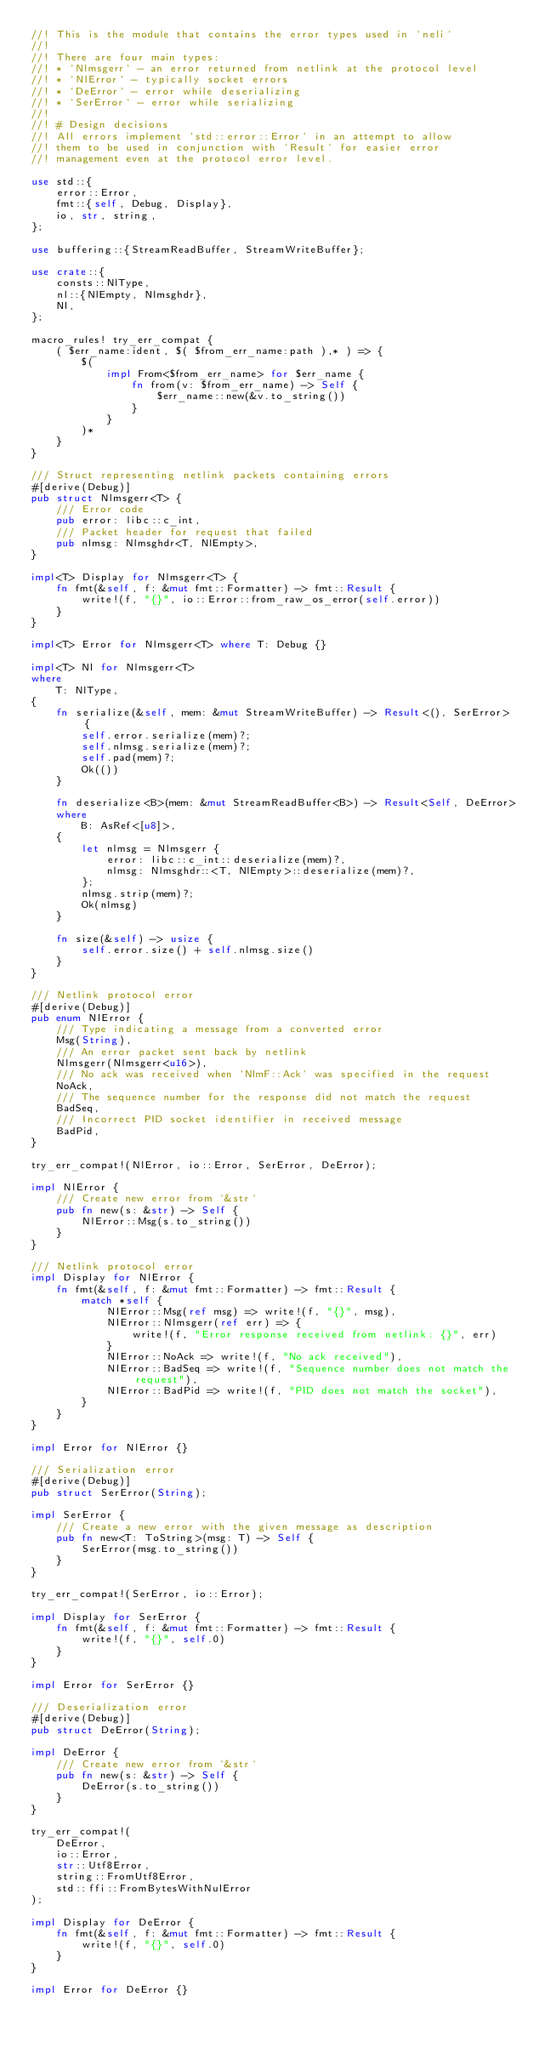<code> <loc_0><loc_0><loc_500><loc_500><_Rust_>//! This is the module that contains the error types used in `neli`
//!
//! There are four main types:
//! * `Nlmsgerr` - an error returned from netlink at the protocol level
//! * `NlError` - typically socket errors
//! * `DeError` - error while deserializing
//! * `SerError` - error while serializing
//!
//! # Design decisions
//! All errors implement `std::error::Error` in an attempt to allow
//! them to be used in conjunction with `Result` for easier error
//! management even at the protocol error level.

use std::{
    error::Error,
    fmt::{self, Debug, Display},
    io, str, string,
};

use buffering::{StreamReadBuffer, StreamWriteBuffer};

use crate::{
    consts::NlType,
    nl::{NlEmpty, Nlmsghdr},
    Nl,
};

macro_rules! try_err_compat {
    ( $err_name:ident, $( $from_err_name:path ),* ) => {
        $(
            impl From<$from_err_name> for $err_name {
                fn from(v: $from_err_name) -> Self {
                    $err_name::new(&v.to_string())
                }
            }
        )*
    }
}

/// Struct representing netlink packets containing errors
#[derive(Debug)]
pub struct Nlmsgerr<T> {
    /// Error code
    pub error: libc::c_int,
    /// Packet header for request that failed
    pub nlmsg: Nlmsghdr<T, NlEmpty>,
}

impl<T> Display for Nlmsgerr<T> {
    fn fmt(&self, f: &mut fmt::Formatter) -> fmt::Result {
        write!(f, "{}", io::Error::from_raw_os_error(self.error))
    }
}

impl<T> Error for Nlmsgerr<T> where T: Debug {}

impl<T> Nl for Nlmsgerr<T>
where
    T: NlType,
{
    fn serialize(&self, mem: &mut StreamWriteBuffer) -> Result<(), SerError> {
        self.error.serialize(mem)?;
        self.nlmsg.serialize(mem)?;
        self.pad(mem)?;
        Ok(())
    }

    fn deserialize<B>(mem: &mut StreamReadBuffer<B>) -> Result<Self, DeError>
    where
        B: AsRef<[u8]>,
    {
        let nlmsg = Nlmsgerr {
            error: libc::c_int::deserialize(mem)?,
            nlmsg: Nlmsghdr::<T, NlEmpty>::deserialize(mem)?,
        };
        nlmsg.strip(mem)?;
        Ok(nlmsg)
    }

    fn size(&self) -> usize {
        self.error.size() + self.nlmsg.size()
    }
}

/// Netlink protocol error
#[derive(Debug)]
pub enum NlError {
    /// Type indicating a message from a converted error
    Msg(String),
    /// An error packet sent back by netlink
    Nlmsgerr(Nlmsgerr<u16>),
    /// No ack was received when `NlmF::Ack` was specified in the request
    NoAck,
    /// The sequence number for the response did not match the request
    BadSeq,
    /// Incorrect PID socket identifier in received message
    BadPid,
}

try_err_compat!(NlError, io::Error, SerError, DeError);

impl NlError {
    /// Create new error from `&str`
    pub fn new(s: &str) -> Self {
        NlError::Msg(s.to_string())
    }
}

/// Netlink protocol error
impl Display for NlError {
    fn fmt(&self, f: &mut fmt::Formatter) -> fmt::Result {
        match *self {
            NlError::Msg(ref msg) => write!(f, "{}", msg),
            NlError::Nlmsgerr(ref err) => {
                write!(f, "Error response received from netlink: {}", err)
            }
            NlError::NoAck => write!(f, "No ack received"),
            NlError::BadSeq => write!(f, "Sequence number does not match the request"),
            NlError::BadPid => write!(f, "PID does not match the socket"),
        }
    }
}

impl Error for NlError {}

/// Serialization error
#[derive(Debug)]
pub struct SerError(String);

impl SerError {
    /// Create a new error with the given message as description
    pub fn new<T: ToString>(msg: T) -> Self {
        SerError(msg.to_string())
    }
}

try_err_compat!(SerError, io::Error);

impl Display for SerError {
    fn fmt(&self, f: &mut fmt::Formatter) -> fmt::Result {
        write!(f, "{}", self.0)
    }
}

impl Error for SerError {}

/// Deserialization error
#[derive(Debug)]
pub struct DeError(String);

impl DeError {
    /// Create new error from `&str`
    pub fn new(s: &str) -> Self {
        DeError(s.to_string())
    }
}

try_err_compat!(
    DeError,
    io::Error,
    str::Utf8Error,
    string::FromUtf8Error,
    std::ffi::FromBytesWithNulError
);

impl Display for DeError {
    fn fmt(&self, f: &mut fmt::Formatter) -> fmt::Result {
        write!(f, "{}", self.0)
    }
}

impl Error for DeError {}
</code> 